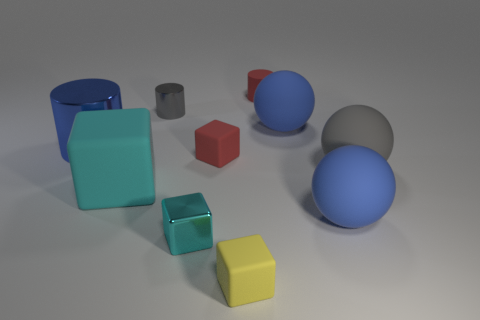There is a big object that is the same color as the small metallic block; what is it made of?
Offer a terse response. Rubber. How many other objects are the same color as the tiny matte cylinder?
Provide a succinct answer. 1. What is the small gray cylinder made of?
Your response must be concise. Metal. Are there any tiny blocks?
Offer a very short reply. Yes. What is the color of the small block behind the large cyan thing?
Your answer should be compact. Red. How many large gray rubber objects are to the left of the matte thing left of the small red matte object that is in front of the big blue cylinder?
Give a very brief answer. 0. There is a object that is on the right side of the small gray object and to the left of the tiny red cube; what is it made of?
Make the answer very short. Metal. Are the red block and the big blue thing to the left of the red matte cylinder made of the same material?
Make the answer very short. No. Is the number of blue metallic objects on the right side of the yellow block greater than the number of large blue rubber balls that are on the left side of the tiny metallic block?
Your answer should be compact. No. What shape is the cyan matte thing?
Offer a very short reply. Cube. 